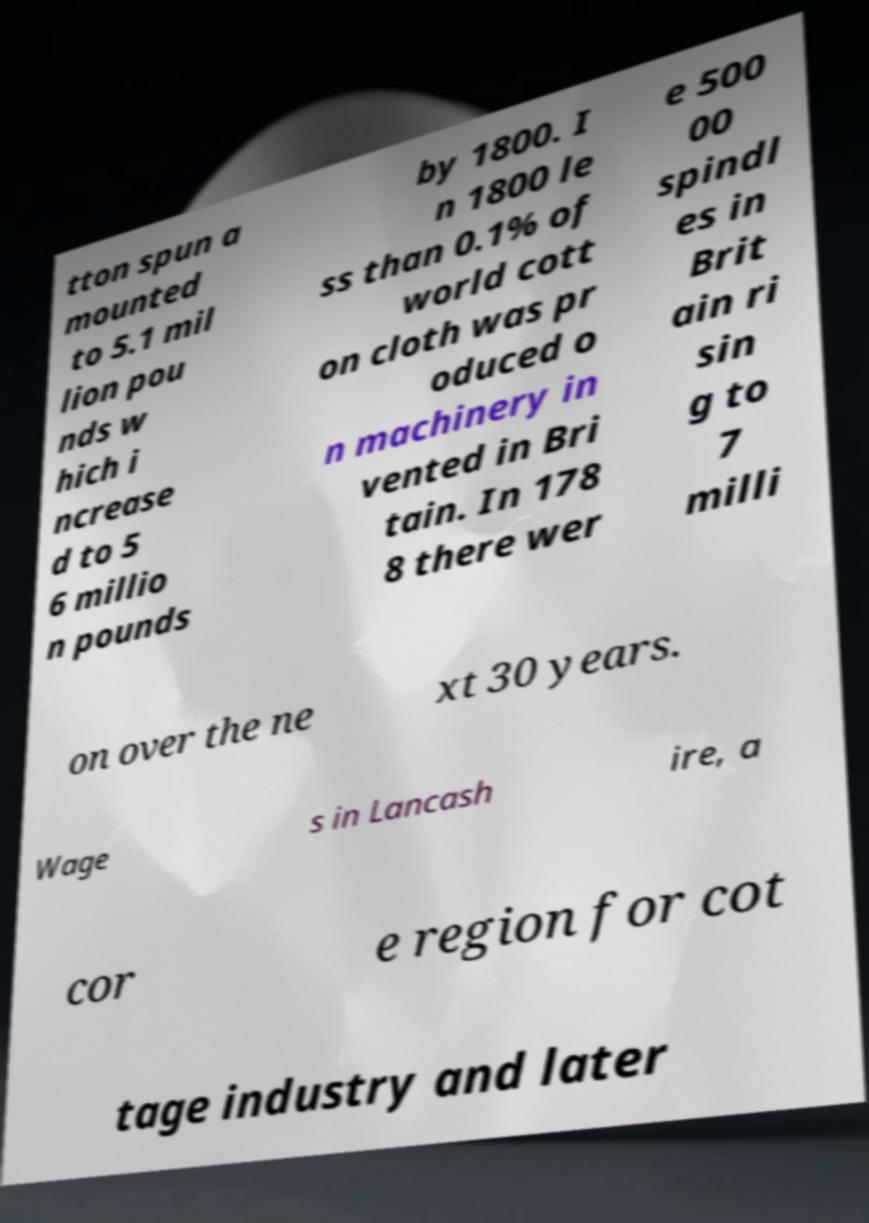Can you read and provide the text displayed in the image?This photo seems to have some interesting text. Can you extract and type it out for me? tton spun a mounted to 5.1 mil lion pou nds w hich i ncrease d to 5 6 millio n pounds by 1800. I n 1800 le ss than 0.1% of world cott on cloth was pr oduced o n machinery in vented in Bri tain. In 178 8 there wer e 500 00 spindl es in Brit ain ri sin g to 7 milli on over the ne xt 30 years. Wage s in Lancash ire, a cor e region for cot tage industry and later 